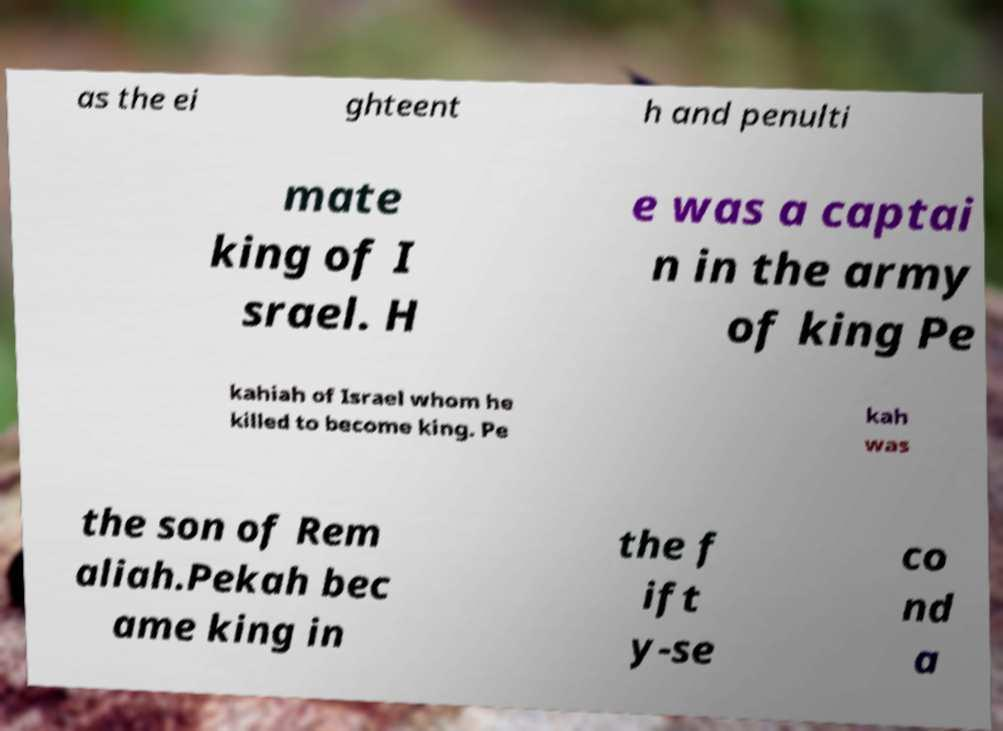Please identify and transcribe the text found in this image. as the ei ghteent h and penulti mate king of I srael. H e was a captai n in the army of king Pe kahiah of Israel whom he killed to become king. Pe kah was the son of Rem aliah.Pekah bec ame king in the f ift y-se co nd a 